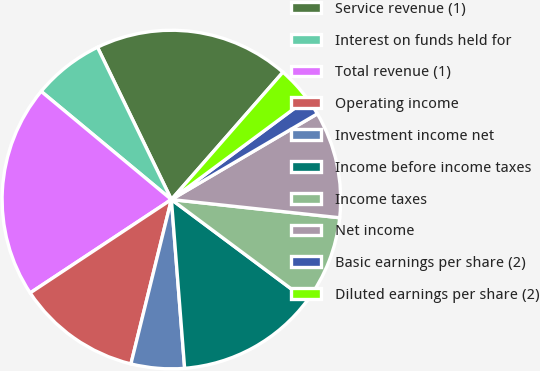<chart> <loc_0><loc_0><loc_500><loc_500><pie_chart><fcel>Service revenue (1)<fcel>Interest on funds held for<fcel>Total revenue (1)<fcel>Operating income<fcel>Investment income net<fcel>Income before income taxes<fcel>Income taxes<fcel>Net income<fcel>Basic earnings per share (2)<fcel>Diluted earnings per share (2)<nl><fcel>18.64%<fcel>6.78%<fcel>20.33%<fcel>11.86%<fcel>5.09%<fcel>13.56%<fcel>8.48%<fcel>10.17%<fcel>1.7%<fcel>3.4%<nl></chart> 